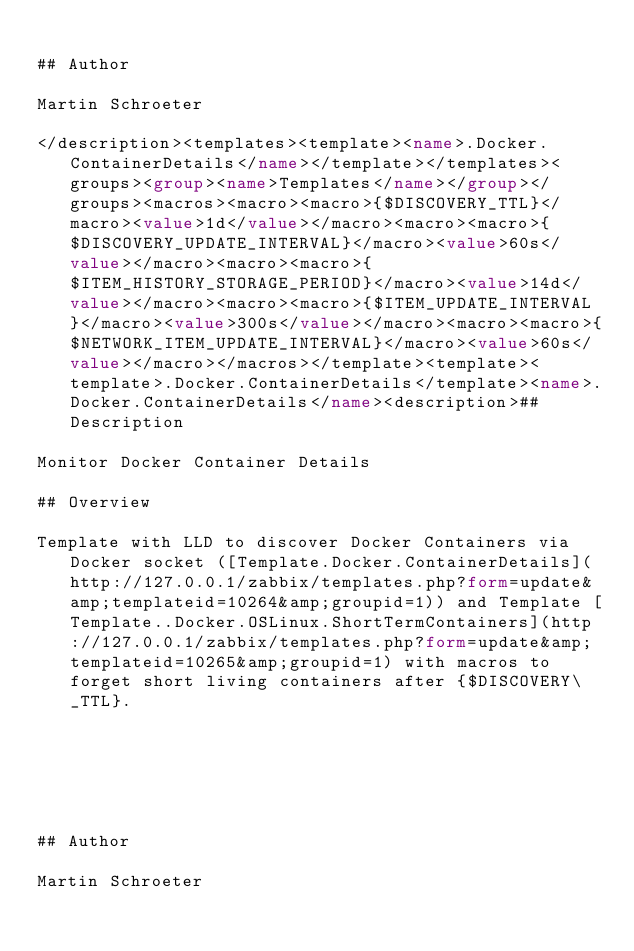Convert code to text. <code><loc_0><loc_0><loc_500><loc_500><_XML_>
## Author

Martin Schroeter

</description><templates><template><name>.Docker.ContainerDetails</name></template></templates><groups><group><name>Templates</name></group></groups><macros><macro><macro>{$DISCOVERY_TTL}</macro><value>1d</value></macro><macro><macro>{$DISCOVERY_UPDATE_INTERVAL}</macro><value>60s</value></macro><macro><macro>{$ITEM_HISTORY_STORAGE_PERIOD}</macro><value>14d</value></macro><macro><macro>{$ITEM_UPDATE_INTERVAL}</macro><value>300s</value></macro><macro><macro>{$NETWORK_ITEM_UPDATE_INTERVAL}</macro><value>60s</value></macro></macros></template><template><template>.Docker.ContainerDetails</template><name>.Docker.ContainerDetails</name><description>## Description

Monitor Docker Container Details

## Overview

Template with LLD to discover Docker Containers via Docker socket ([Template.Docker.ContainerDetails](http://127.0.0.1/zabbix/templates.php?form=update&amp;templateid=10264&amp;groupid=1)) and Template [Template..Docker.OSLinux.ShortTermContainers](http://127.0.0.1/zabbix/templates.php?form=update&amp;templateid=10265&amp;groupid=1) with macros to forget short living containers after {$DISCOVERY\_TTL}.


 



## Author

Martin Schroeter
</code> 